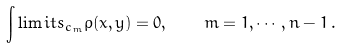<formula> <loc_0><loc_0><loc_500><loc_500>\int \lim i t s _ { c _ { m } } \rho ( x , y ) = 0 , \quad m = 1 , \cdots , n - 1 \, .</formula> 